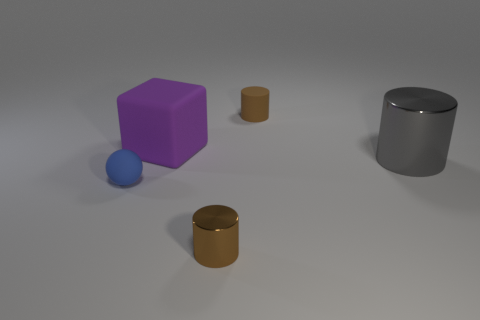What is the size of the metallic cylinder in front of the gray cylinder?
Ensure brevity in your answer.  Small. How many small things are red shiny balls or matte cylinders?
Your answer should be compact. 1. What is the color of the cylinder that is to the left of the big gray object and behind the small blue sphere?
Your response must be concise. Brown. Are there any brown metal things that have the same shape as the big purple thing?
Ensure brevity in your answer.  No. What material is the big cube?
Keep it short and to the point. Rubber. There is a purple rubber thing; are there any big cylinders behind it?
Provide a succinct answer. No. Is the small metal thing the same shape as the brown rubber thing?
Keep it short and to the point. Yes. What number of other objects are the same size as the purple cube?
Ensure brevity in your answer.  1. What number of things are either small cylinders behind the matte ball or big blue spheres?
Make the answer very short. 1. The tiny matte sphere is what color?
Offer a very short reply. Blue. 